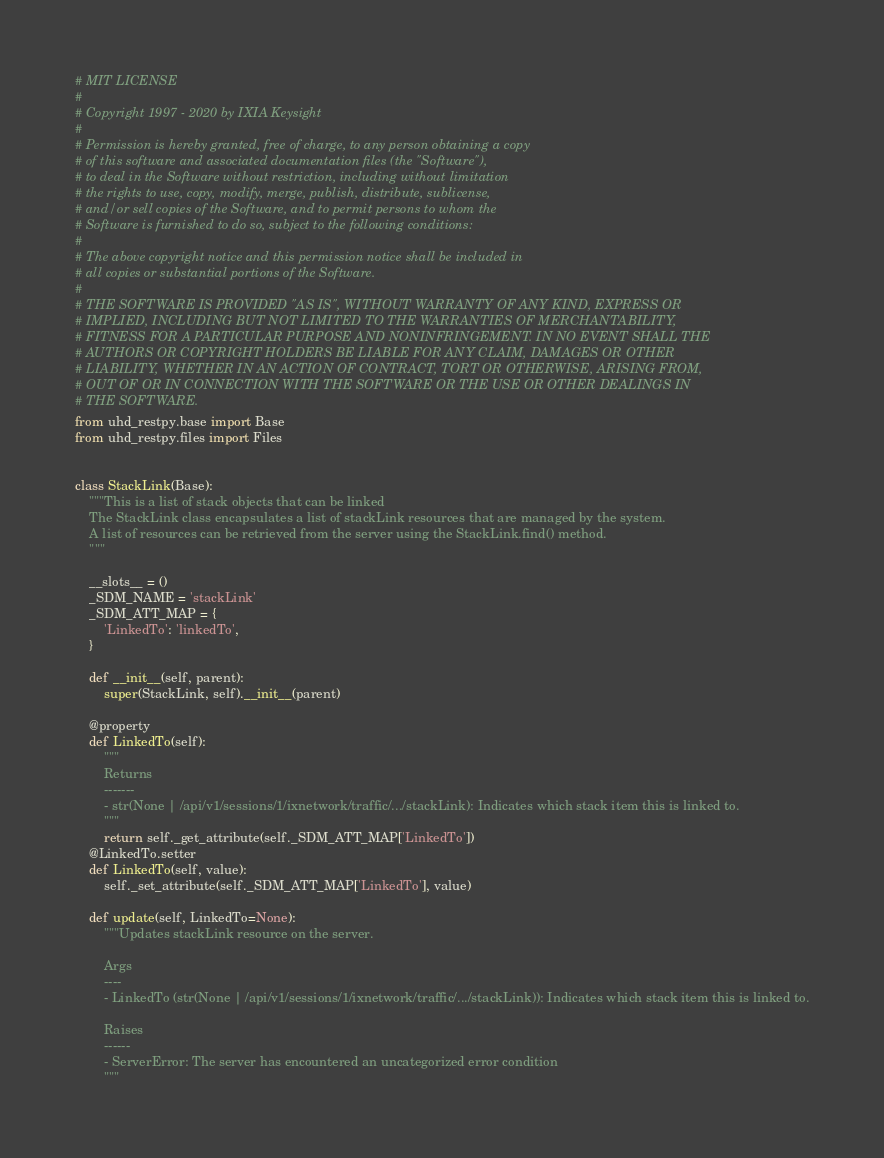<code> <loc_0><loc_0><loc_500><loc_500><_Python_># MIT LICENSE
#
# Copyright 1997 - 2020 by IXIA Keysight
#
# Permission is hereby granted, free of charge, to any person obtaining a copy
# of this software and associated documentation files (the "Software"),
# to deal in the Software without restriction, including without limitation
# the rights to use, copy, modify, merge, publish, distribute, sublicense,
# and/or sell copies of the Software, and to permit persons to whom the
# Software is furnished to do so, subject to the following conditions:
#
# The above copyright notice and this permission notice shall be included in
# all copies or substantial portions of the Software.
#
# THE SOFTWARE IS PROVIDED "AS IS", WITHOUT WARRANTY OF ANY KIND, EXPRESS OR
# IMPLIED, INCLUDING BUT NOT LIMITED TO THE WARRANTIES OF MERCHANTABILITY,
# FITNESS FOR A PARTICULAR PURPOSE AND NONINFRINGEMENT. IN NO EVENT SHALL THE
# AUTHORS OR COPYRIGHT HOLDERS BE LIABLE FOR ANY CLAIM, DAMAGES OR OTHER
# LIABILITY, WHETHER IN AN ACTION OF CONTRACT, TORT OR OTHERWISE, ARISING FROM,
# OUT OF OR IN CONNECTION WITH THE SOFTWARE OR THE USE OR OTHER DEALINGS IN
# THE SOFTWARE. 
from uhd_restpy.base import Base
from uhd_restpy.files import Files


class StackLink(Base):
    """This is a list of stack objects that can be linked
    The StackLink class encapsulates a list of stackLink resources that are managed by the system.
    A list of resources can be retrieved from the server using the StackLink.find() method.
    """

    __slots__ = ()
    _SDM_NAME = 'stackLink'
    _SDM_ATT_MAP = {
        'LinkedTo': 'linkedTo',
    }

    def __init__(self, parent):
        super(StackLink, self).__init__(parent)

    @property
    def LinkedTo(self):
        """
        Returns
        -------
        - str(None | /api/v1/sessions/1/ixnetwork/traffic/.../stackLink): Indicates which stack item this is linked to.
        """
        return self._get_attribute(self._SDM_ATT_MAP['LinkedTo'])
    @LinkedTo.setter
    def LinkedTo(self, value):
        self._set_attribute(self._SDM_ATT_MAP['LinkedTo'], value)

    def update(self, LinkedTo=None):
        """Updates stackLink resource on the server.

        Args
        ----
        - LinkedTo (str(None | /api/v1/sessions/1/ixnetwork/traffic/.../stackLink)): Indicates which stack item this is linked to.

        Raises
        ------
        - ServerError: The server has encountered an uncategorized error condition
        """</code> 